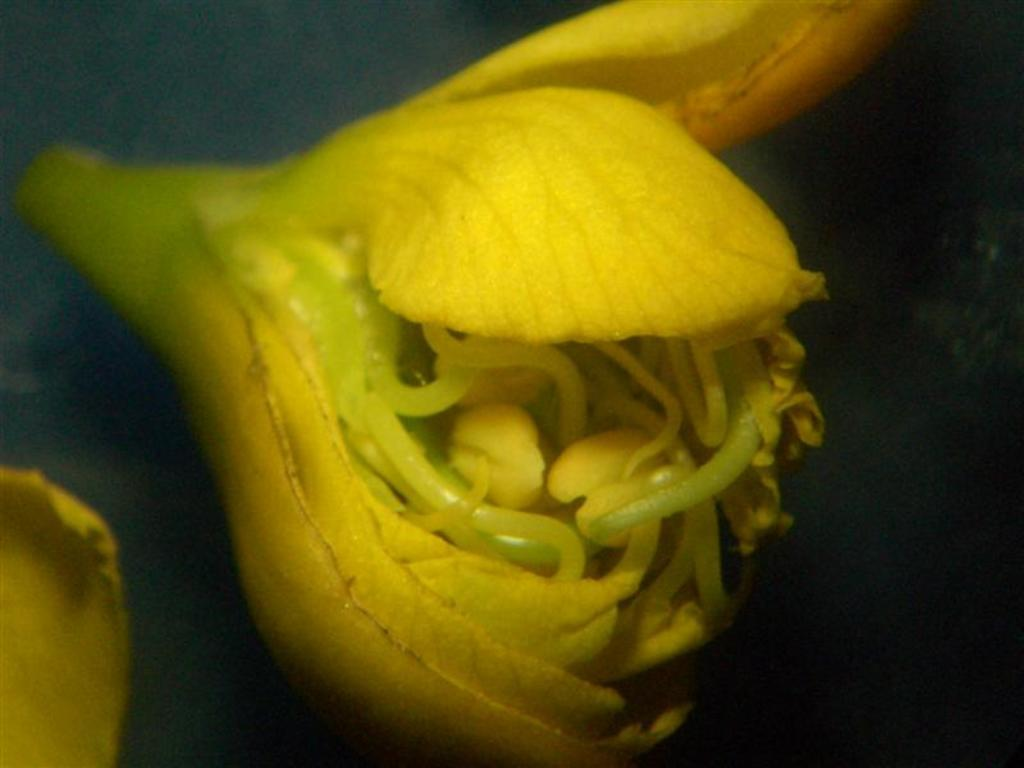What is the main subject of the image? The main subject of the image is a flower. Can you describe any other objects or features in the image? Yes, there is an object on the bottom left corner of the image. What type of prose is being recited by the flower in the image? There is no indication in the image that the flower is reciting any prose. How many beds are visible in the image? There are no beds present in the image. 